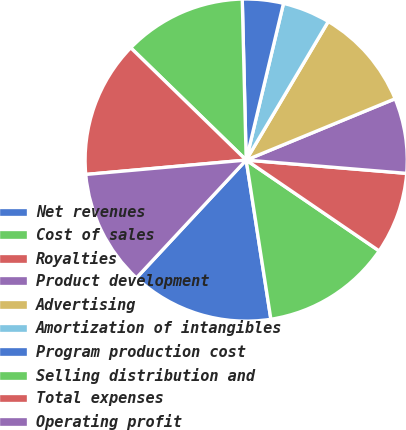Convert chart. <chart><loc_0><loc_0><loc_500><loc_500><pie_chart><fcel>Net revenues<fcel>Cost of sales<fcel>Royalties<fcel>Product development<fcel>Advertising<fcel>Amortization of intangibles<fcel>Program production cost<fcel>Selling distribution and<fcel>Total expenses<fcel>Operating profit<nl><fcel>14.38%<fcel>13.01%<fcel>8.22%<fcel>7.53%<fcel>10.27%<fcel>4.79%<fcel>4.11%<fcel>12.33%<fcel>13.7%<fcel>11.64%<nl></chart> 